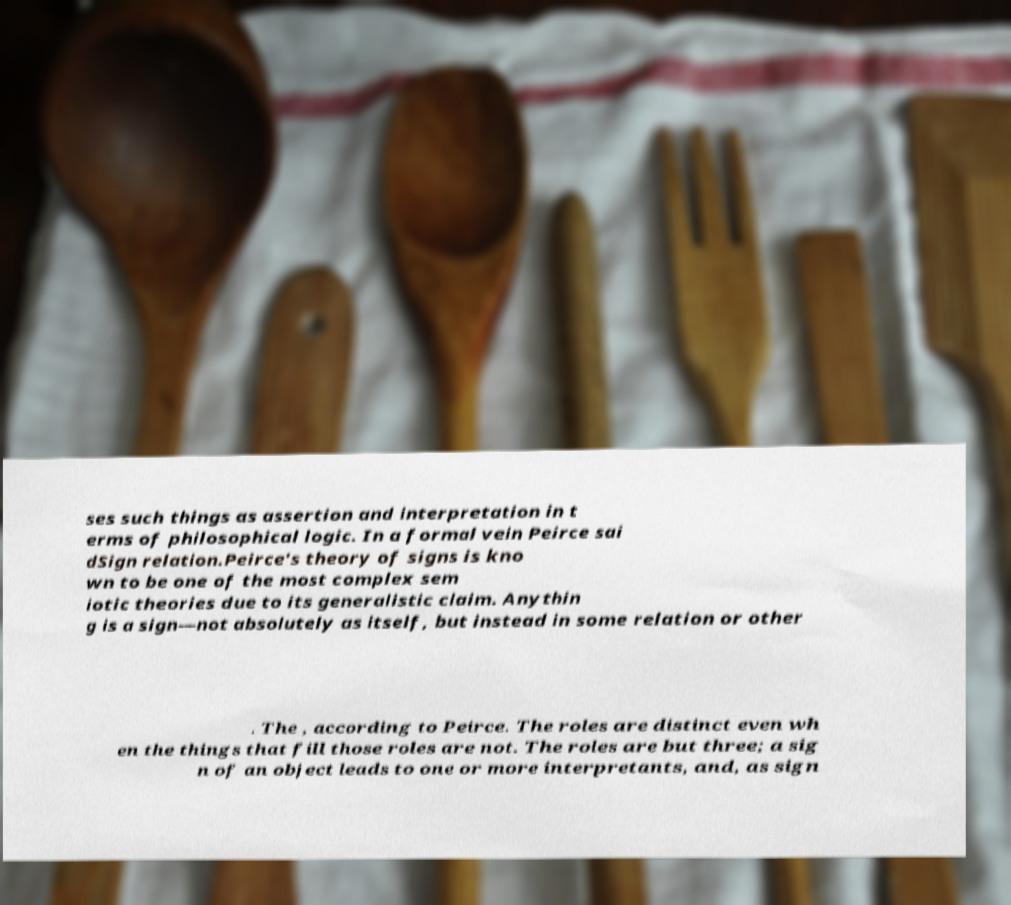I need the written content from this picture converted into text. Can you do that? ses such things as assertion and interpretation in t erms of philosophical logic. In a formal vein Peirce sai dSign relation.Peirce's theory of signs is kno wn to be one of the most complex sem iotic theories due to its generalistic claim. Anythin g is a sign—not absolutely as itself, but instead in some relation or other . The , according to Peirce. The roles are distinct even wh en the things that fill those roles are not. The roles are but three; a sig n of an object leads to one or more interpretants, and, as sign 